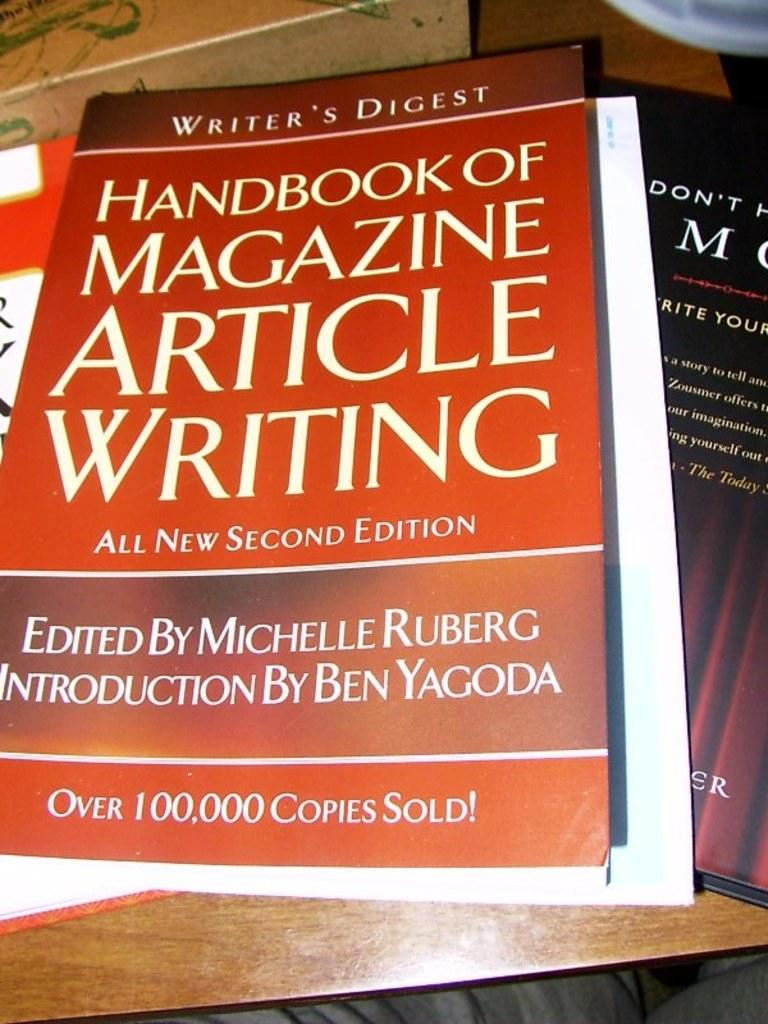<image>
Relay a brief, clear account of the picture shown. A copy of the Handbook of Magazine Article Writing edited by Michelle Ruberg. 